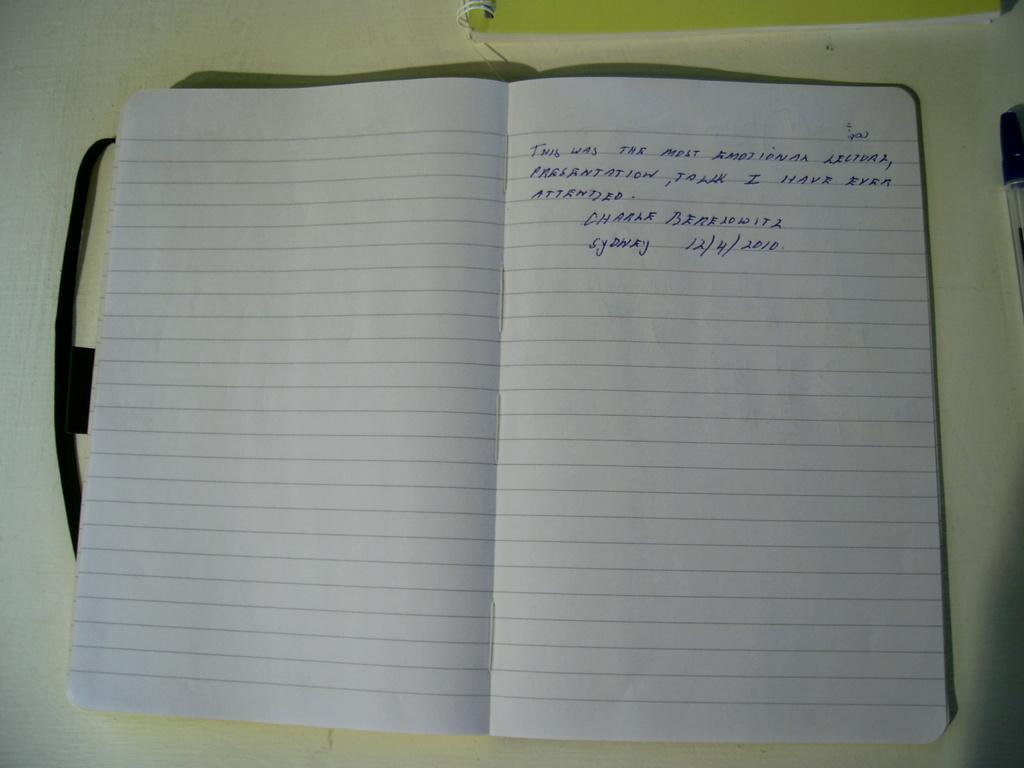What date is written in this journal?
Provide a succinct answer. 12/4/2010. Which city is featured in this entry?
Your response must be concise. Sydney. 